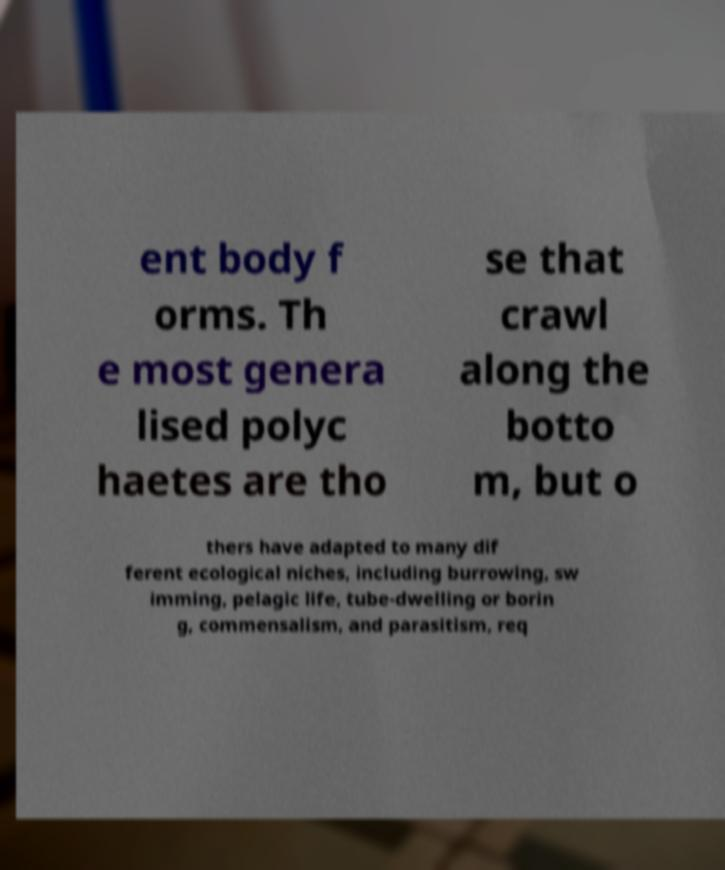There's text embedded in this image that I need extracted. Can you transcribe it verbatim? ent body f orms. Th e most genera lised polyc haetes are tho se that crawl along the botto m, but o thers have adapted to many dif ferent ecological niches, including burrowing, sw imming, pelagic life, tube-dwelling or borin g, commensalism, and parasitism, req 